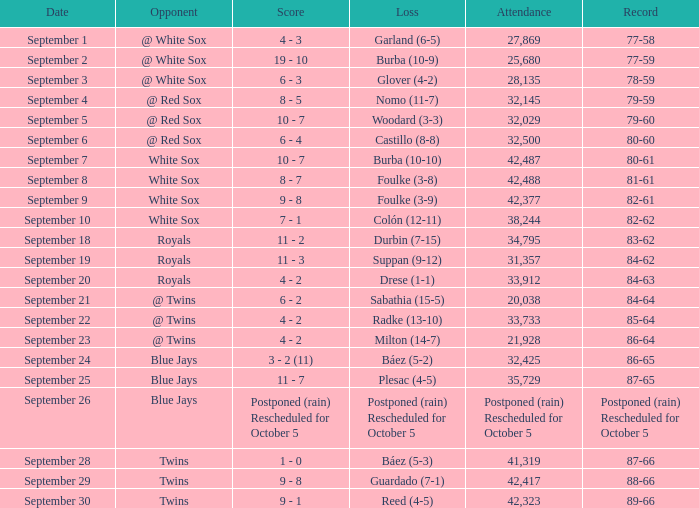With 28,135 people present, what is the record for that particular game? 78-59. 